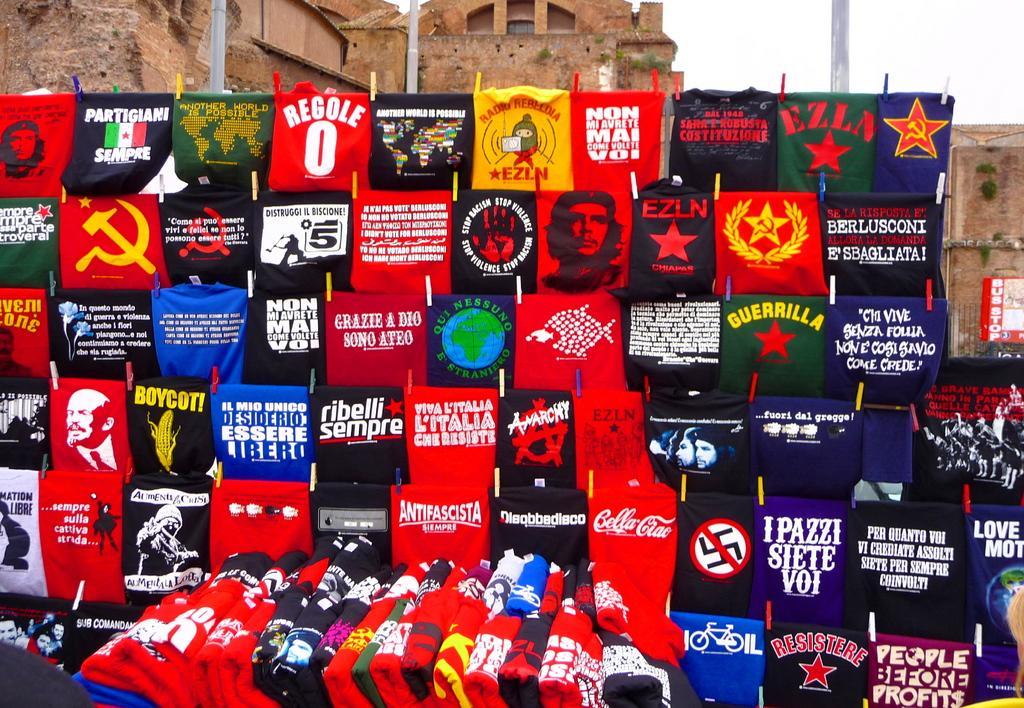Describe this image in one or two sentences. In this image we can see some clothes in different colors with text and some pictures. In the background, we can see the building. 